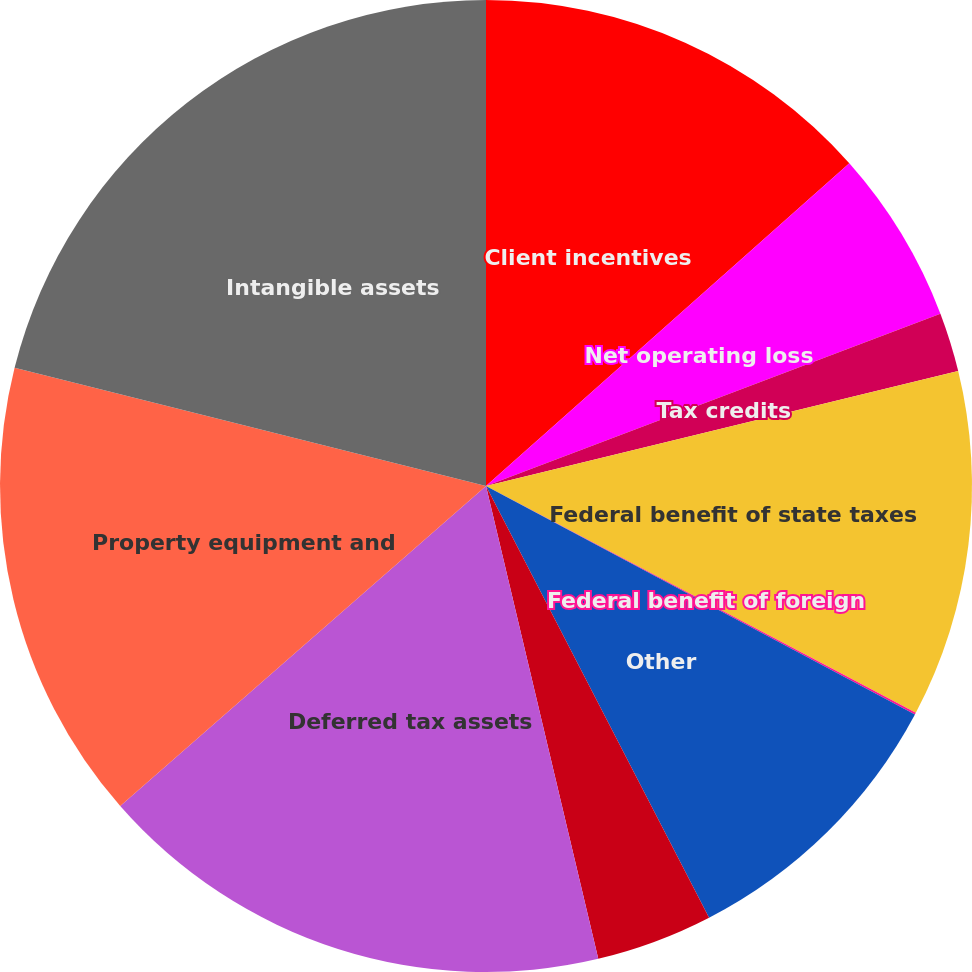Convert chart. <chart><loc_0><loc_0><loc_500><loc_500><pie_chart><fcel>Client incentives<fcel>Net operating loss<fcel>Tax credits<fcel>Federal benefit of state taxes<fcel>Federal benefit of foreign<fcel>Other<fcel>Valuation allowance<fcel>Deferred tax assets<fcel>Property equipment and<fcel>Intangible assets<nl><fcel>13.44%<fcel>5.79%<fcel>1.97%<fcel>11.53%<fcel>0.06%<fcel>9.62%<fcel>3.88%<fcel>17.27%<fcel>15.35%<fcel>21.09%<nl></chart> 